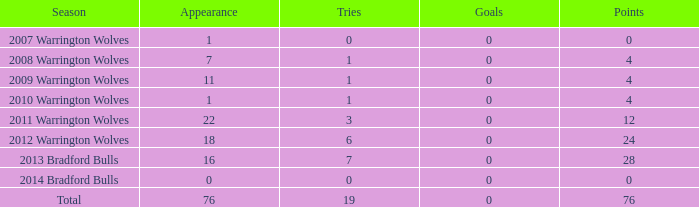In how many cases are attempts 0 and appearance negative? 0.0. 